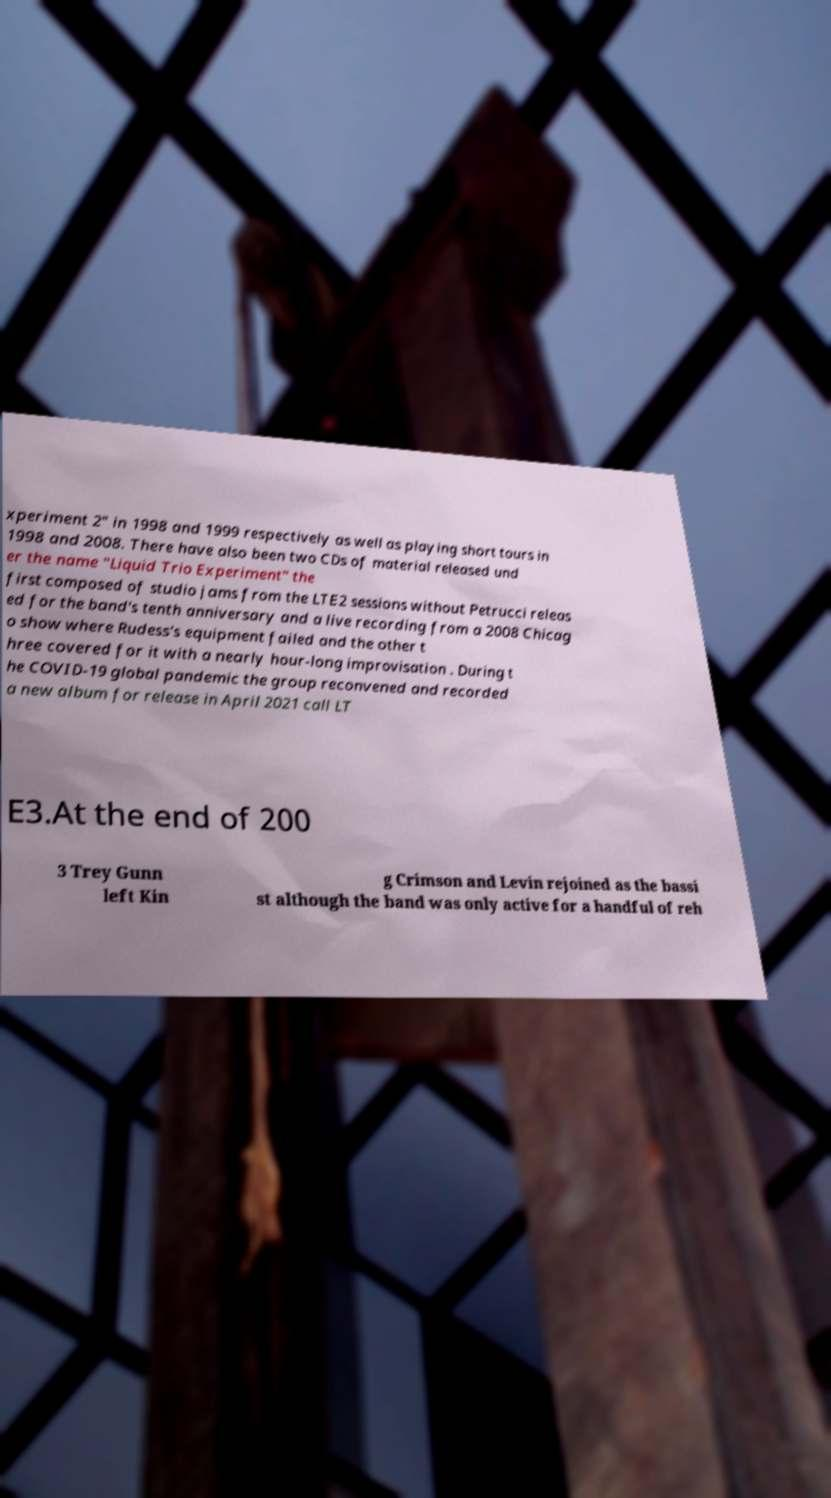Could you extract and type out the text from this image? xperiment 2" in 1998 and 1999 respectively as well as playing short tours in 1998 and 2008. There have also been two CDs of material released und er the name "Liquid Trio Experiment" the first composed of studio jams from the LTE2 sessions without Petrucci releas ed for the band's tenth anniversary and a live recording from a 2008 Chicag o show where Rudess's equipment failed and the other t hree covered for it with a nearly hour-long improvisation . During t he COVID-19 global pandemic the group reconvened and recorded a new album for release in April 2021 call LT E3.At the end of 200 3 Trey Gunn left Kin g Crimson and Levin rejoined as the bassi st although the band was only active for a handful of reh 